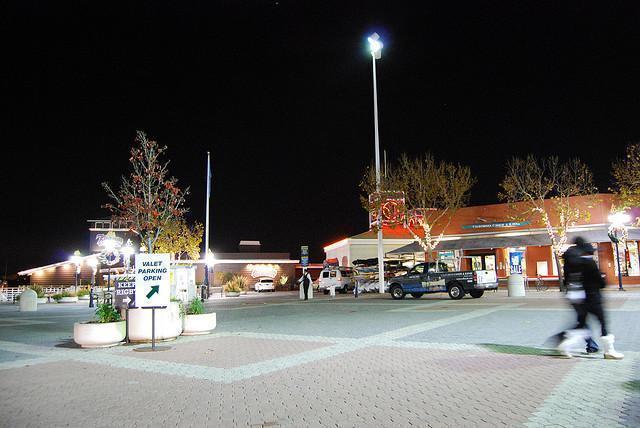What fast food restaurant is seen in the background?
Select the accurate response from the four choices given to answer the question.
Options: Taco bell, mcdonald's, wendys, burger king. Mcdonald's. 